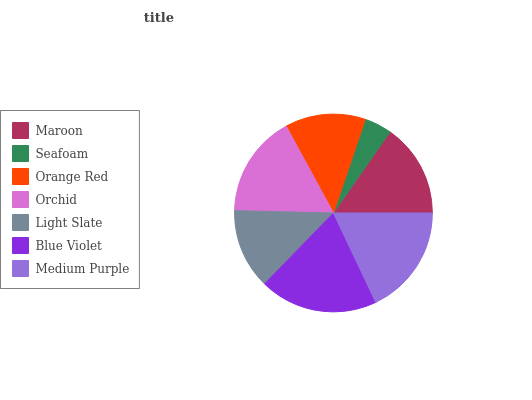Is Seafoam the minimum?
Answer yes or no. Yes. Is Blue Violet the maximum?
Answer yes or no. Yes. Is Orange Red the minimum?
Answer yes or no. No. Is Orange Red the maximum?
Answer yes or no. No. Is Orange Red greater than Seafoam?
Answer yes or no. Yes. Is Seafoam less than Orange Red?
Answer yes or no. Yes. Is Seafoam greater than Orange Red?
Answer yes or no. No. Is Orange Red less than Seafoam?
Answer yes or no. No. Is Maroon the high median?
Answer yes or no. Yes. Is Maroon the low median?
Answer yes or no. Yes. Is Orchid the high median?
Answer yes or no. No. Is Blue Violet the low median?
Answer yes or no. No. 